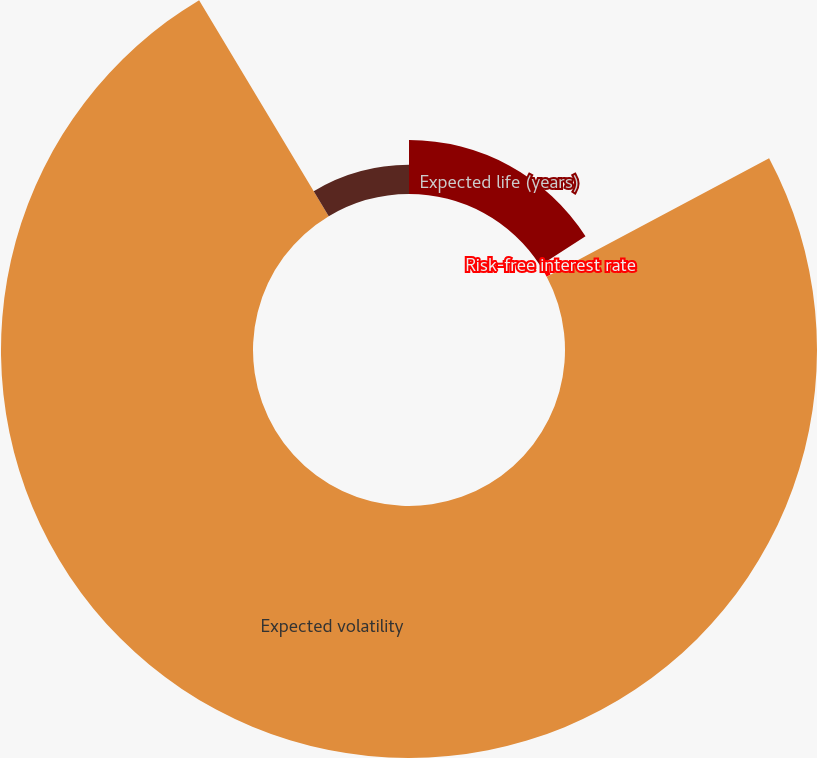Convert chart to OTSL. <chart><loc_0><loc_0><loc_500><loc_500><pie_chart><fcel>Expected life (years)<fcel>Risk-free interest rate<fcel>Expected volatility<fcel>Dividend yield<nl><fcel>15.89%<fcel>1.32%<fcel>74.19%<fcel>8.6%<nl></chart> 